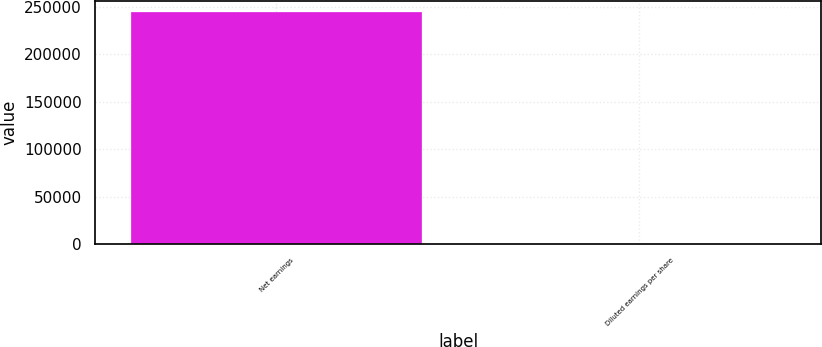Convert chart. <chart><loc_0><loc_0><loc_500><loc_500><bar_chart><fcel>Net earnings<fcel>Diluted earnings per share<nl><fcel>243940<fcel>0.45<nl></chart> 